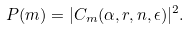Convert formula to latex. <formula><loc_0><loc_0><loc_500><loc_500>P ( m ) = | C _ { m } ( \alpha , r , n , \epsilon ) | ^ { 2 } .</formula> 